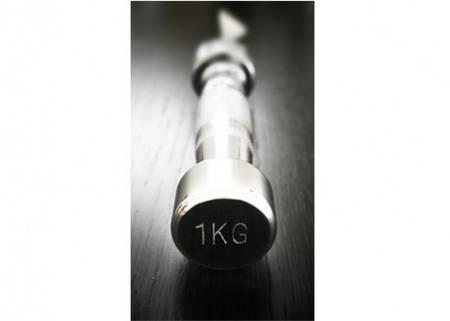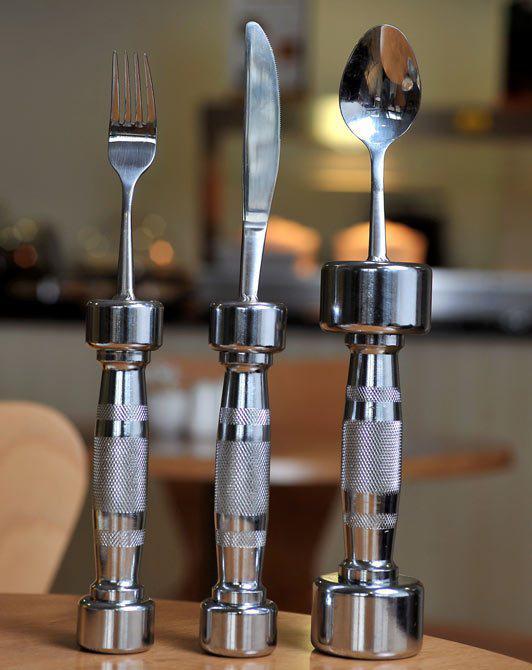The first image is the image on the left, the second image is the image on the right. Assess this claim about the two images: "One image shows a matched set of knife, fork, and spoon utensils.". Correct or not? Answer yes or no. Yes. 